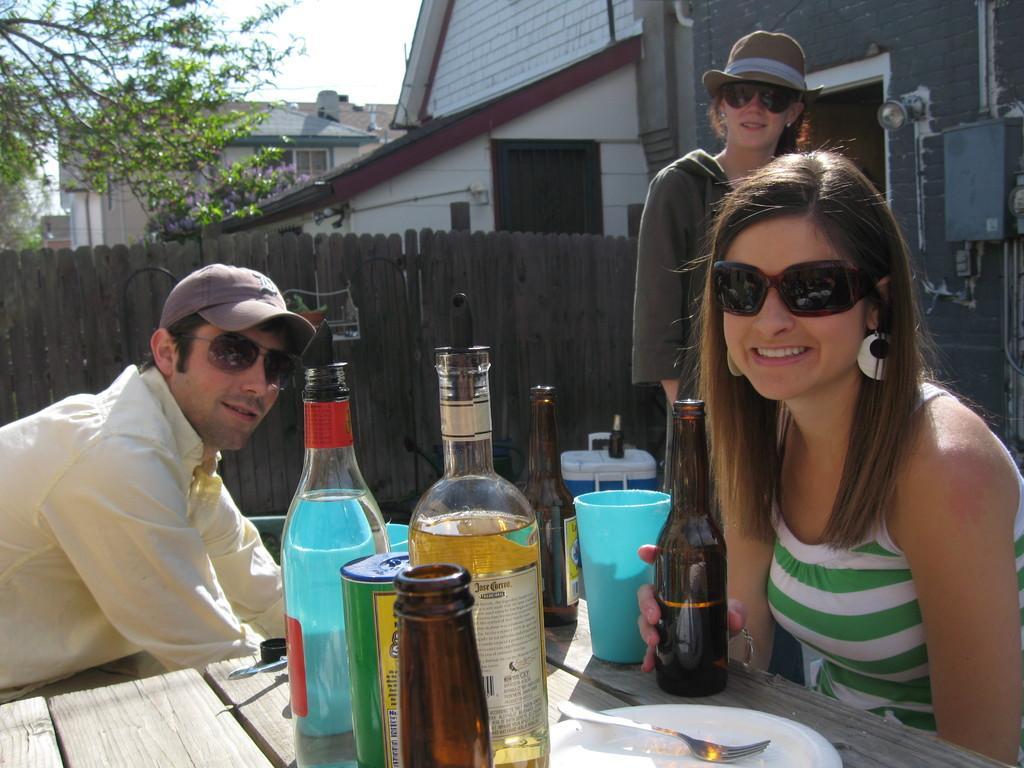Please provide a concise description of this image. In this image,there are three people. two are women and a man. Two of them are sitting at a table with a few bottles in front of them. The woman at the right side is holding a beer bottle in her hand. There is a glass beside the beer bottle. There is plate with a fork on it. The man at the table wears a half white shirt. He has a cap and spectacles. The woman standing behind wears a hat and goggles. There is barrier wall behind her. At a distance,there are some houses and few trees 